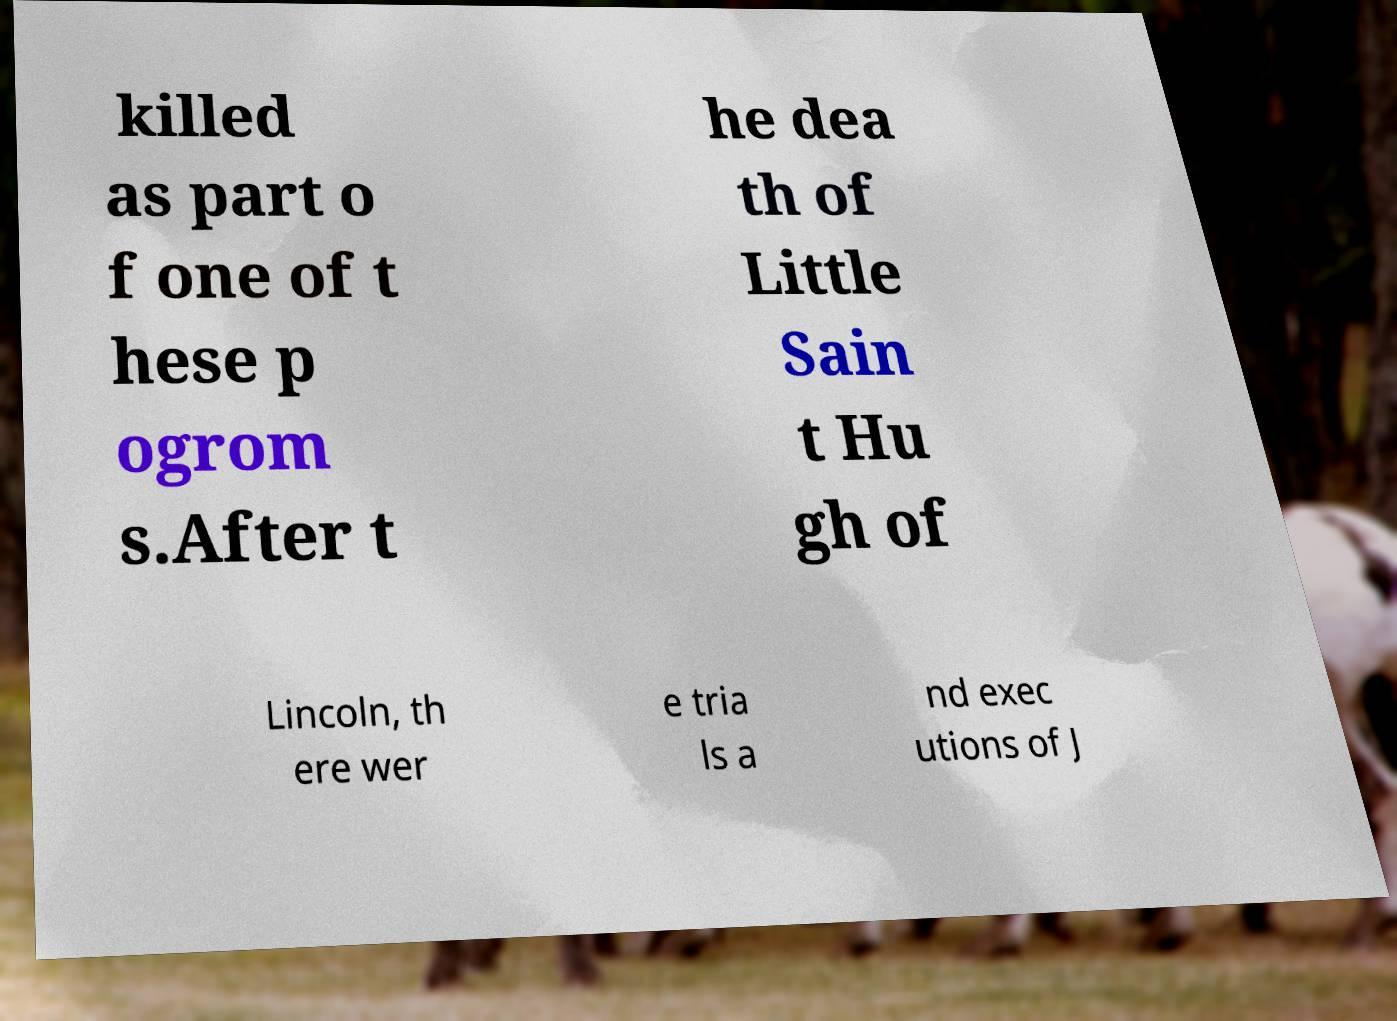Can you accurately transcribe the text from the provided image for me? killed as part o f one of t hese p ogrom s.After t he dea th of Little Sain t Hu gh of Lincoln, th ere wer e tria ls a nd exec utions of J 